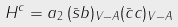<formula> <loc_0><loc_0><loc_500><loc_500>H ^ { c } = a _ { 2 } \, ( \bar { s } b ) _ { V - A } ( \bar { c } c ) _ { V - A }</formula> 